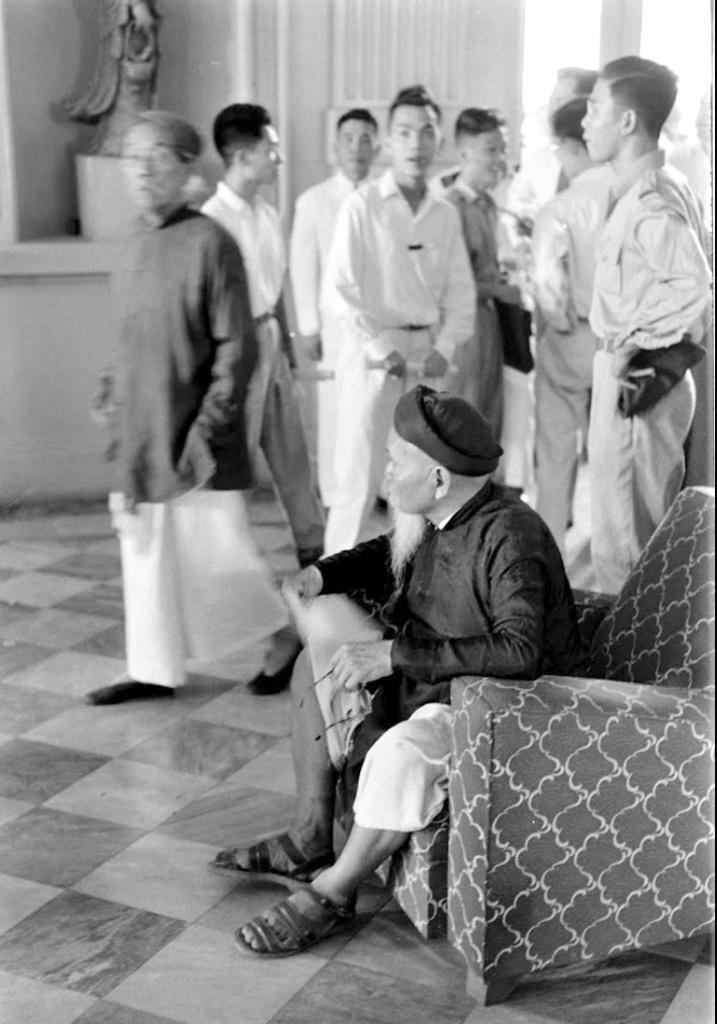In one or two sentences, can you explain what this image depicts? On the right side of the image we can see a man sitting on the sofa. In the background there are people and there is a statue. 